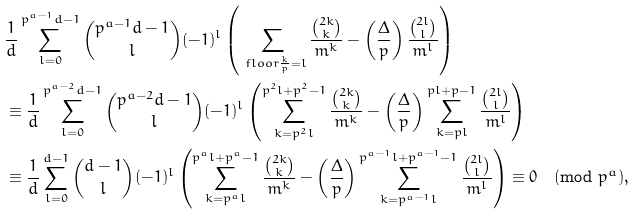Convert formula to latex. <formula><loc_0><loc_0><loc_500><loc_500>& \frac { 1 } { d } \sum _ { l = 0 } ^ { p ^ { a - 1 } d - 1 } \binom { p ^ { a - 1 } d - 1 } { l } ( - 1 ) ^ { l } \left ( \sum _ { \ f l o o r { \frac { k } { p } } = l } \frac { \binom { 2 k } { k } } { m ^ { k } } - \left ( \frac { \Delta } { p } \right ) \frac { \binom { 2 l } { l } } { m ^ { l } } \right ) \\ & \equiv \frac { 1 } { d } \sum _ { l = 0 } ^ { p ^ { a - 2 } d - 1 } \binom { p ^ { a - 2 } d - 1 } { l } ( - 1 ) ^ { l } \left ( \sum _ { k = p ^ { 2 } l } ^ { p ^ { 2 } l + p ^ { 2 } - 1 } \frac { \binom { 2 k } { k } } { m ^ { k } } - \left ( \frac { \Delta } { p } \right ) \sum _ { k = p l } ^ { p l + p - 1 } \frac { \binom { 2 l } { l } } { m ^ { l } } \right ) \\ & \equiv \frac { 1 } { d } \sum _ { l = 0 } ^ { d - 1 } \binom { d - 1 } { l } ( - 1 ) ^ { l } \left ( \sum _ { k = p ^ { a } l } ^ { p ^ { a } l + p ^ { a } - 1 } \frac { \binom { 2 k } { k } } { m ^ { k } } - \left ( \frac { \Delta } { p } \right ) \sum _ { k = p ^ { a - 1 } l } ^ { p ^ { a - 1 } l + p ^ { a - 1 } - 1 } \frac { \binom { 2 l } { l } } { m ^ { l } } \right ) \equiv 0 \pmod { p ^ { a } } ,</formula> 